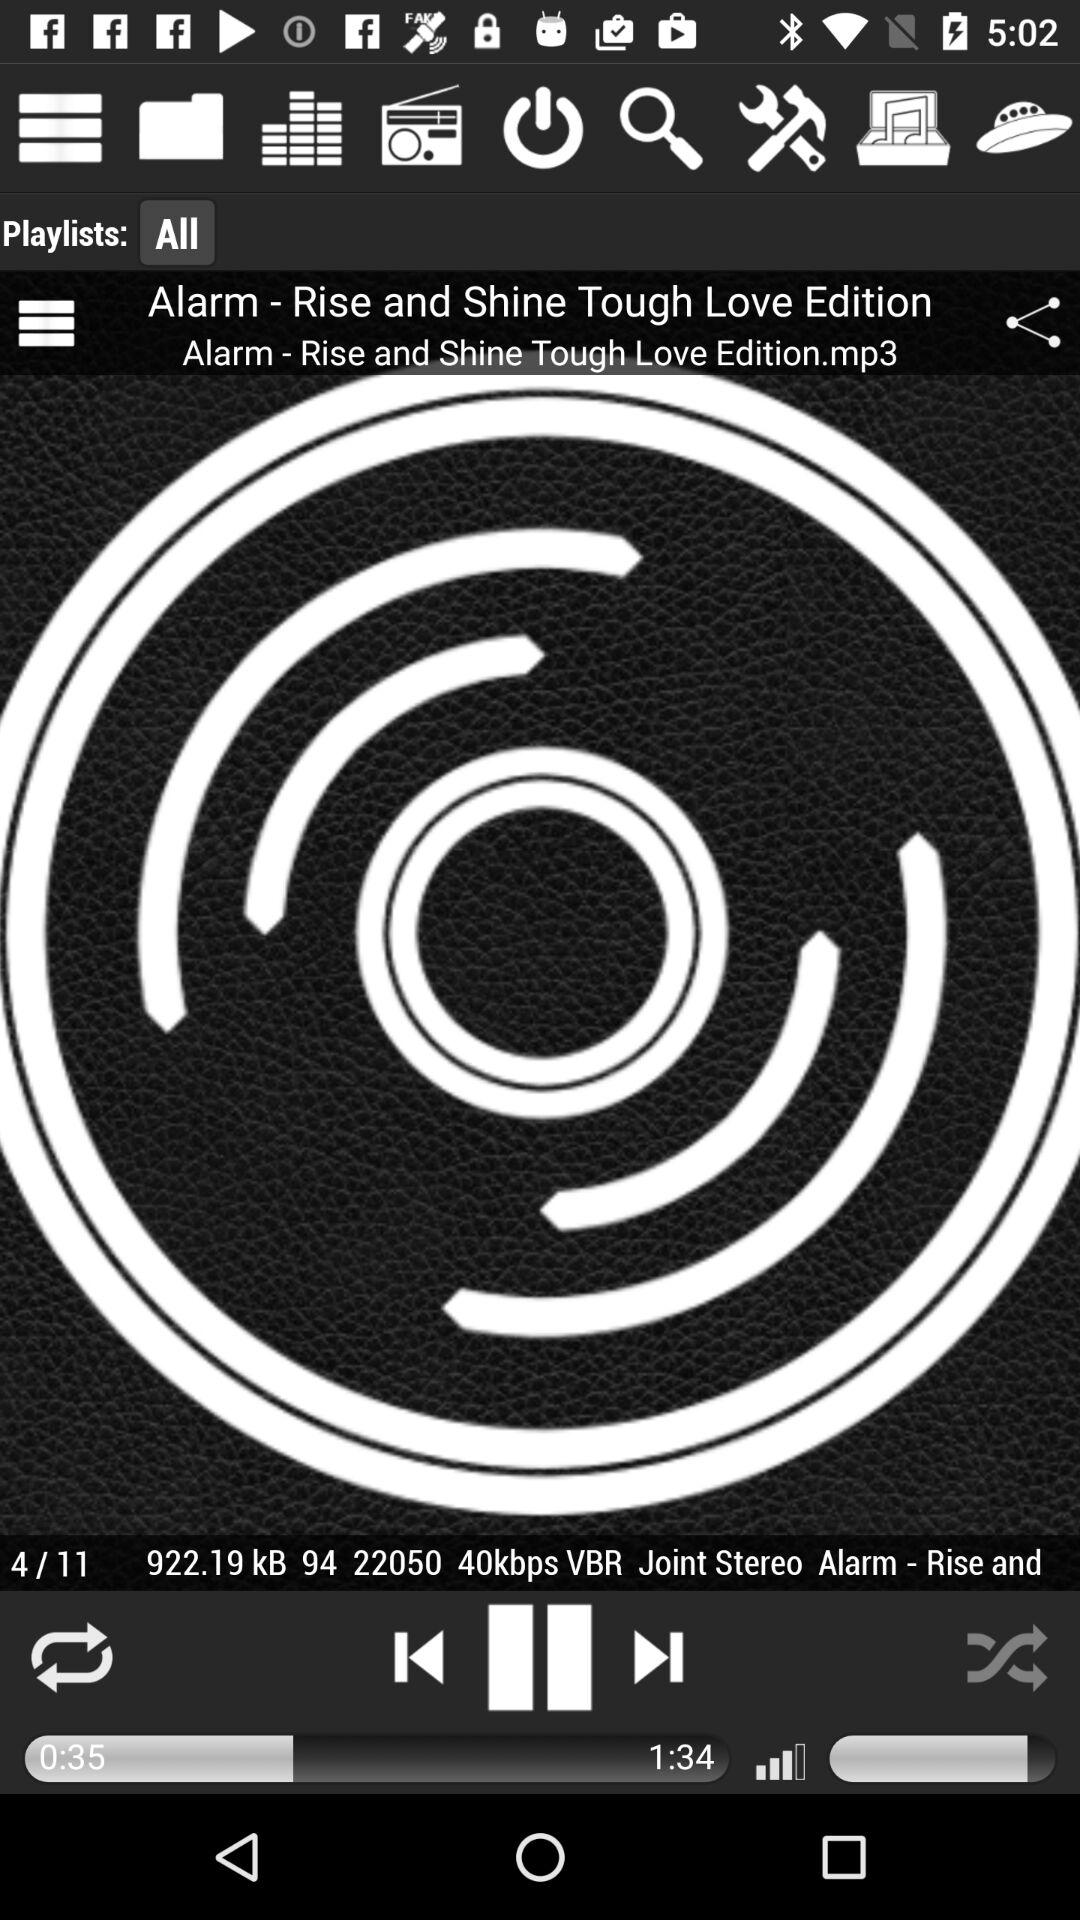How long the audio has been played? The audio has been played for 35 seconds. 